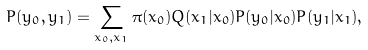<formula> <loc_0><loc_0><loc_500><loc_500>P ( y _ { 0 } , y _ { 1 } ) = \sum _ { x _ { 0 } , x _ { 1 } } \pi ( x _ { 0 } ) Q ( x _ { 1 } | x _ { 0 } ) P ( y _ { 0 } | x _ { 0 } ) P ( y _ { 1 } | x _ { 1 } ) ,</formula> 